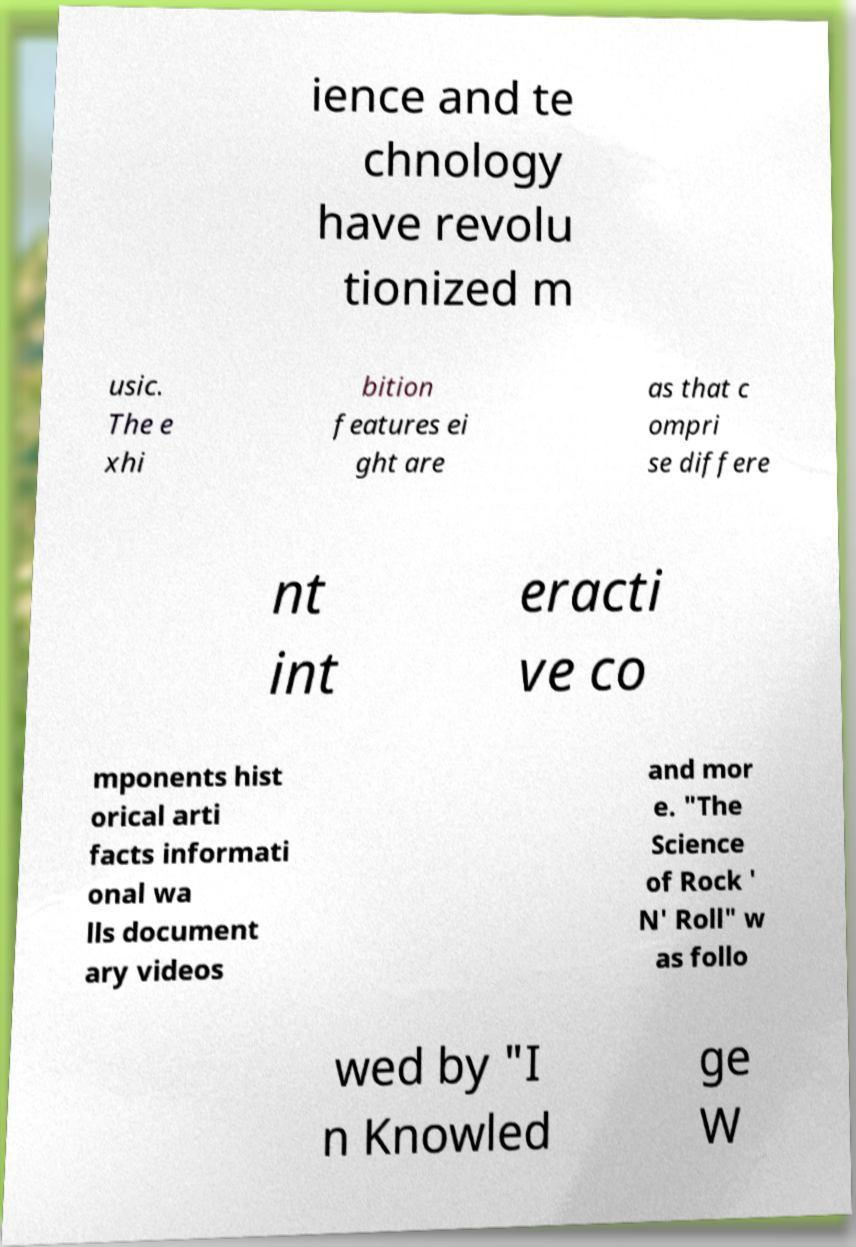Can you accurately transcribe the text from the provided image for me? ience and te chnology have revolu tionized m usic. The e xhi bition features ei ght are as that c ompri se differe nt int eracti ve co mponents hist orical arti facts informati onal wa lls document ary videos and mor e. "The Science of Rock ' N' Roll" w as follo wed by "I n Knowled ge W 